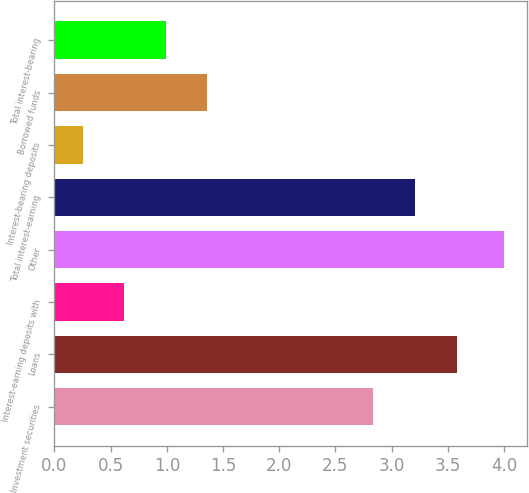Convert chart. <chart><loc_0><loc_0><loc_500><loc_500><bar_chart><fcel>Investment securities<fcel>Loans<fcel>Interest-earning deposits with<fcel>Other<fcel>Total interest-earning<fcel>Interest-bearing deposits<fcel>Borrowed funds<fcel>Total interest-bearing<nl><fcel>2.83<fcel>3.58<fcel>0.62<fcel>4<fcel>3.21<fcel>0.25<fcel>1.36<fcel>0.99<nl></chart> 